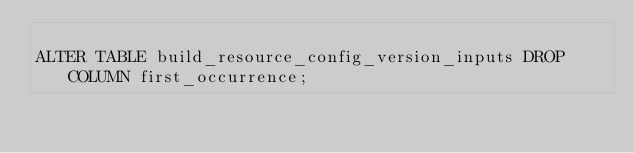Convert code to text. <code><loc_0><loc_0><loc_500><loc_500><_SQL_>
ALTER TABLE build_resource_config_version_inputs DROP COLUMN first_occurrence;

</code> 